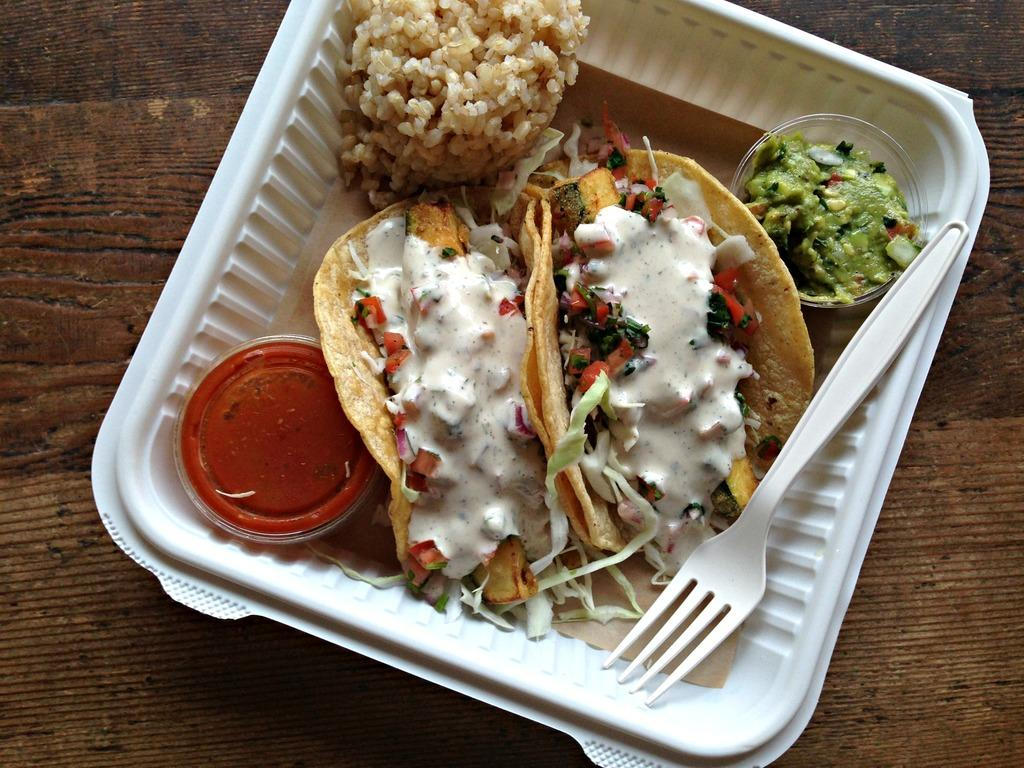What piece of furniture is present in the image? There is a table in the image. What is in the bowl that is visible on the table? There is a bowl containing food in the image. What utensil is present in the image? There is a fork in the image. What type of condiment is present in the image? There is sauce in the image. How many bowls are placed on the table in the image? There are bowls placed on the table in the image. How many geese are crossing the road in the image? There are no geese or roads present in the image. What type of trucks can be seen in the image? There are no trucks present in the image. 